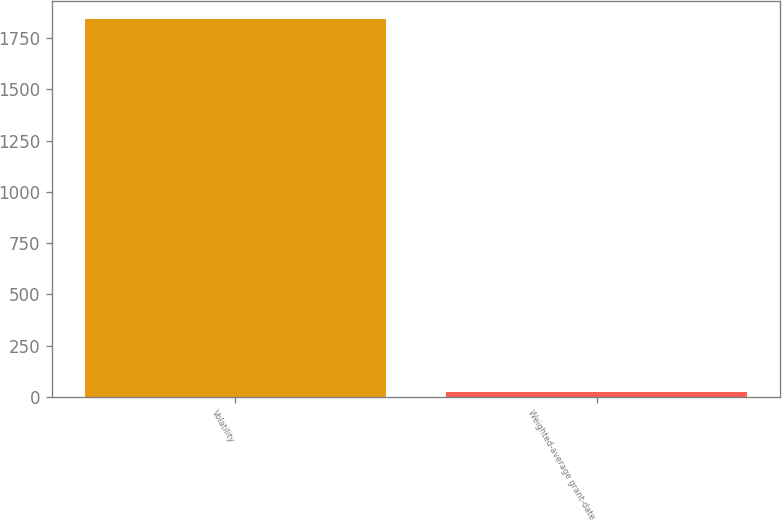Convert chart to OTSL. <chart><loc_0><loc_0><loc_500><loc_500><bar_chart><fcel>Volatility<fcel>Weighted-average grant-date<nl><fcel>1841<fcel>23.41<nl></chart> 